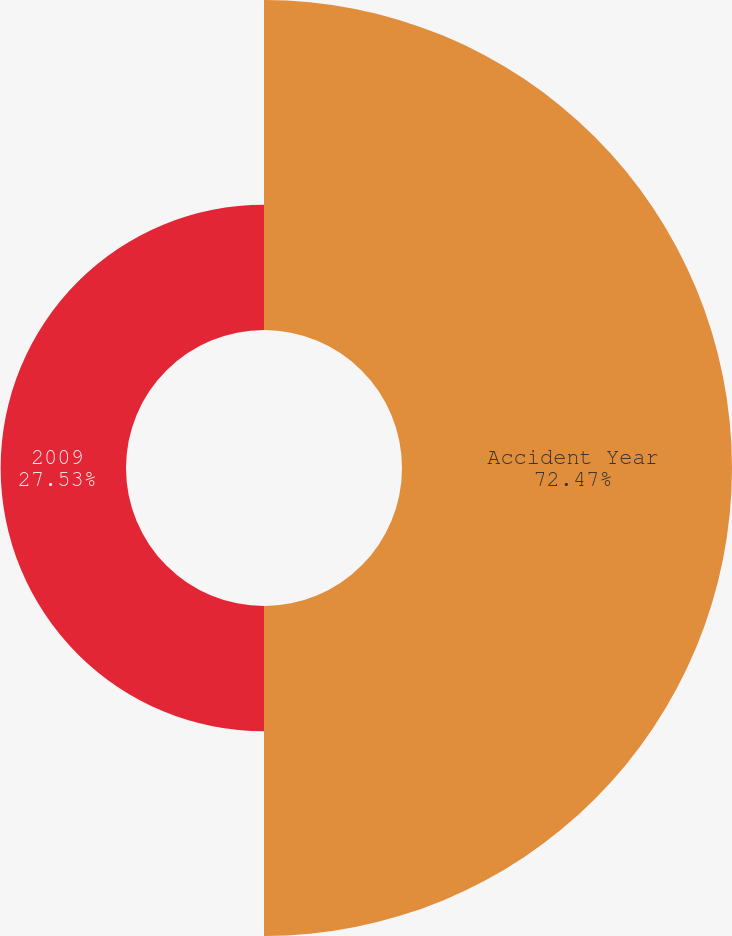<chart> <loc_0><loc_0><loc_500><loc_500><pie_chart><fcel>Accident Year<fcel>2009<nl><fcel>72.47%<fcel>27.53%<nl></chart> 